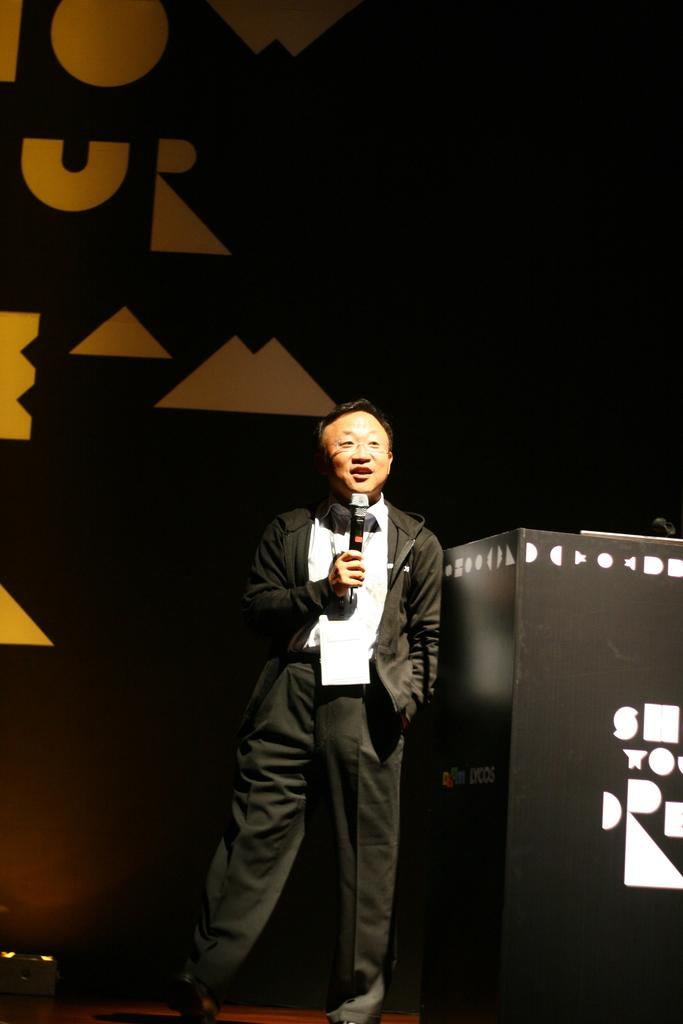What is the man in the image doing? The man is standing in the image and holding a microphone. What is the man wearing in the image? The man is wearing a suit, a shirt, and trousers. What object is present in the image that the man might be using for his activity? There is a podium in the image that the man might be using. What can be seen in the background of the image? There is a hoarding in the background of the image. Can you see a sail in the image? No, there is no sail present in the image. Is the man in the image using a crook to hold the microphone? No, the man is not using a crook to hold the microphone; he is holding it with his hand. 